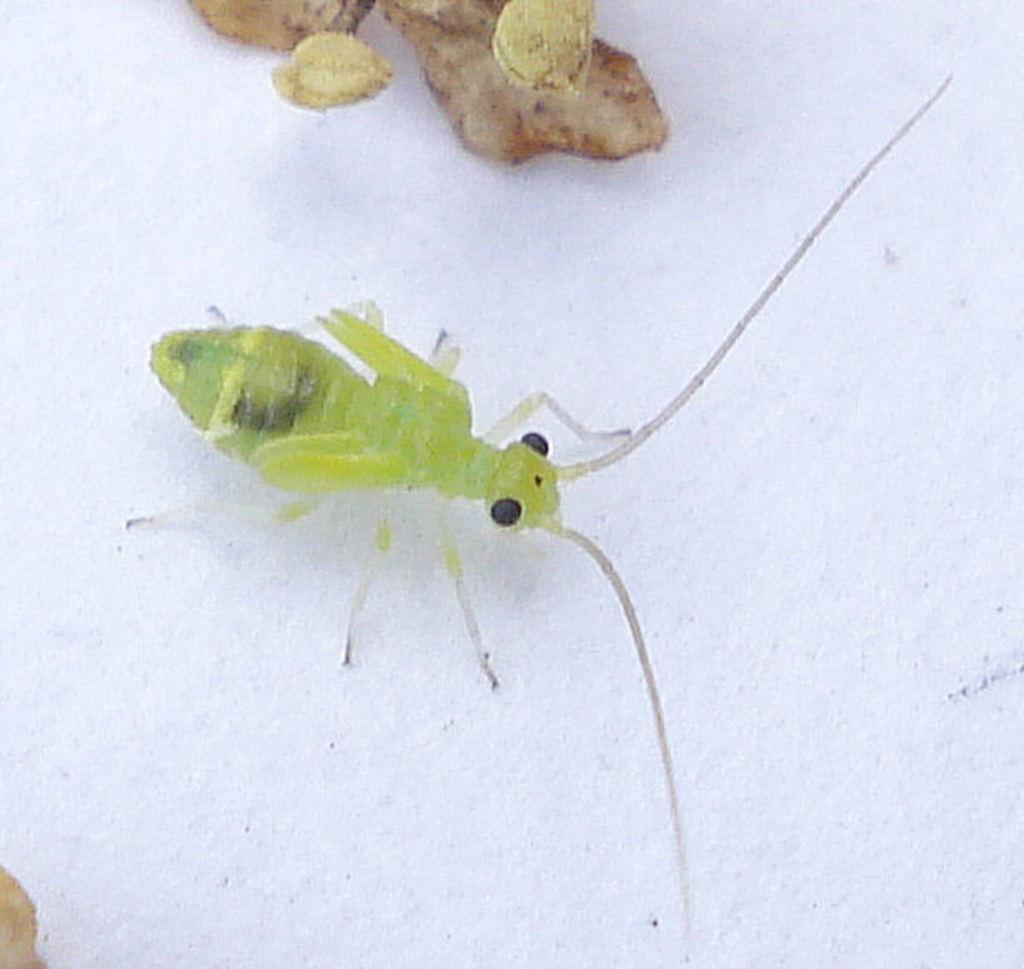What type of creature can be seen in the image? There is an insect in the image. What is present on the table in the image? There are ginger pieces on a table in the image. What type of dress is the insect wearing in the image? There is no dress present in the image, as the insect is not wearing any clothing. 